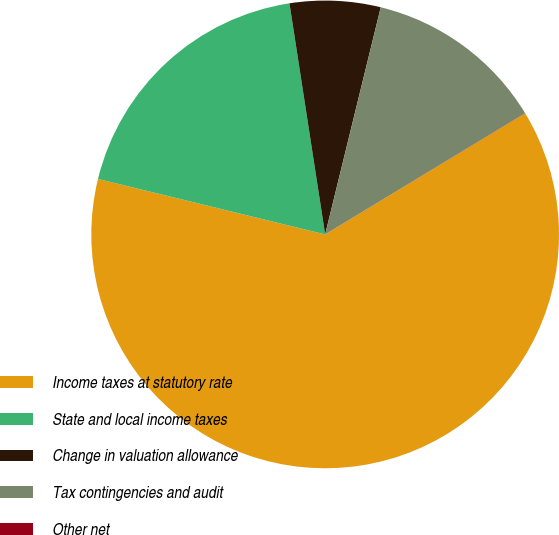Convert chart. <chart><loc_0><loc_0><loc_500><loc_500><pie_chart><fcel>Income taxes at statutory rate<fcel>State and local income taxes<fcel>Change in valuation allowance<fcel>Tax contingencies and audit<fcel>Other net<nl><fcel>62.48%<fcel>18.75%<fcel>6.26%<fcel>12.5%<fcel>0.01%<nl></chart> 